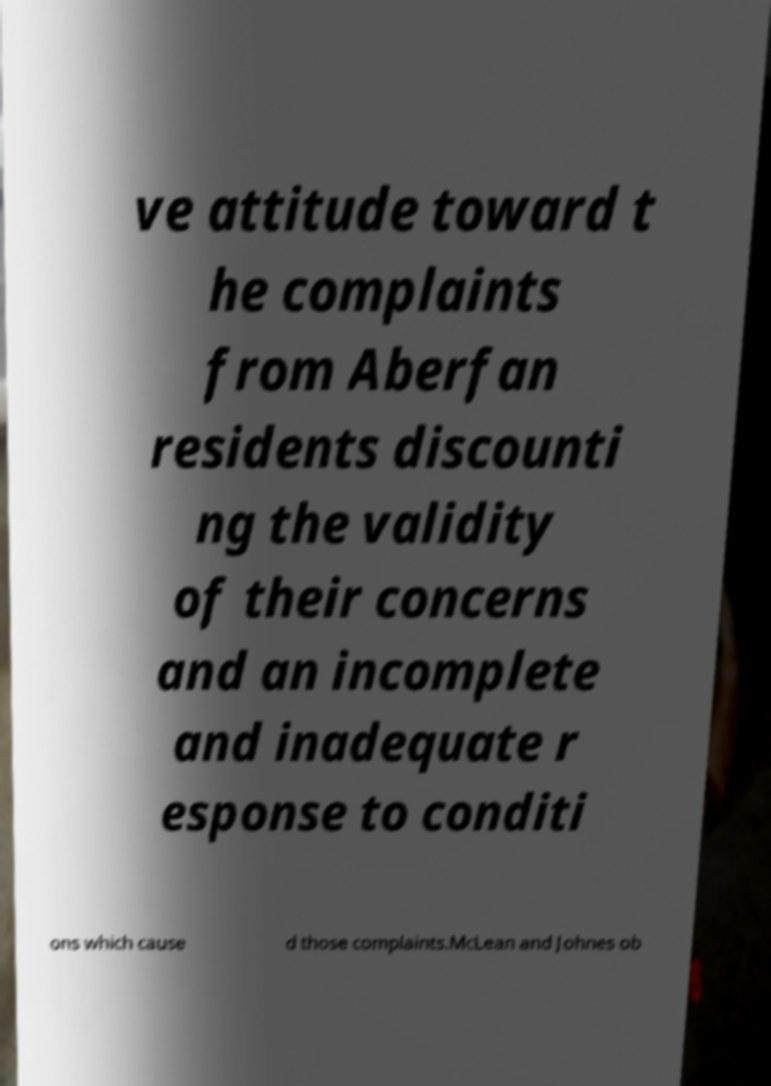Could you assist in decoding the text presented in this image and type it out clearly? ve attitude toward t he complaints from Aberfan residents discounti ng the validity of their concerns and an incomplete and inadequate r esponse to conditi ons which cause d those complaints.McLean and Johnes ob 